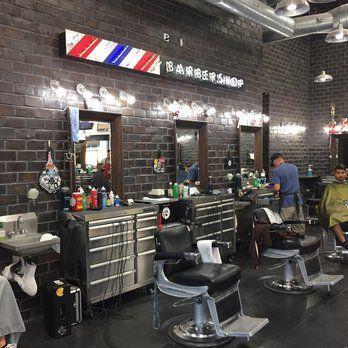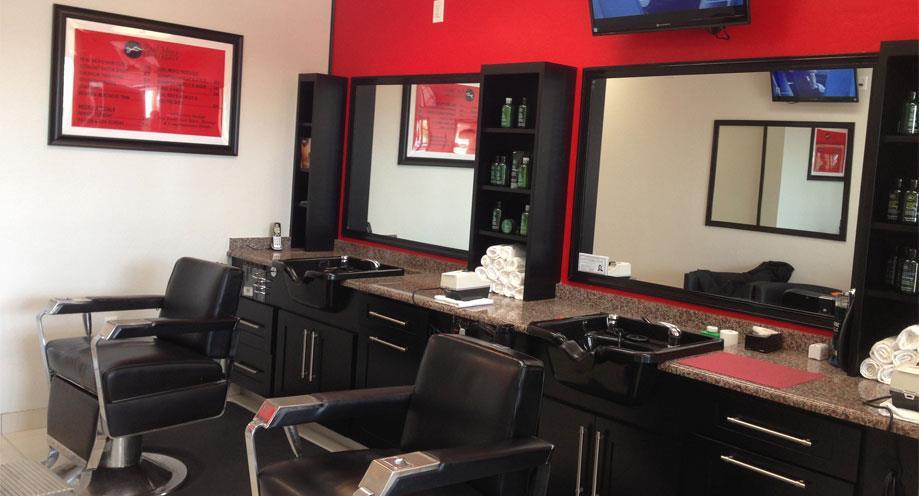The first image is the image on the left, the second image is the image on the right. Evaluate the accuracy of this statement regarding the images: "One image shows a barber shop with a black and white checkerboard floor.". Is it true? Answer yes or no. No. The first image is the image on the left, the second image is the image on the right. For the images displayed, is the sentence "There are exactly two barber chairs in the image on the right." factually correct? Answer yes or no. Yes. 